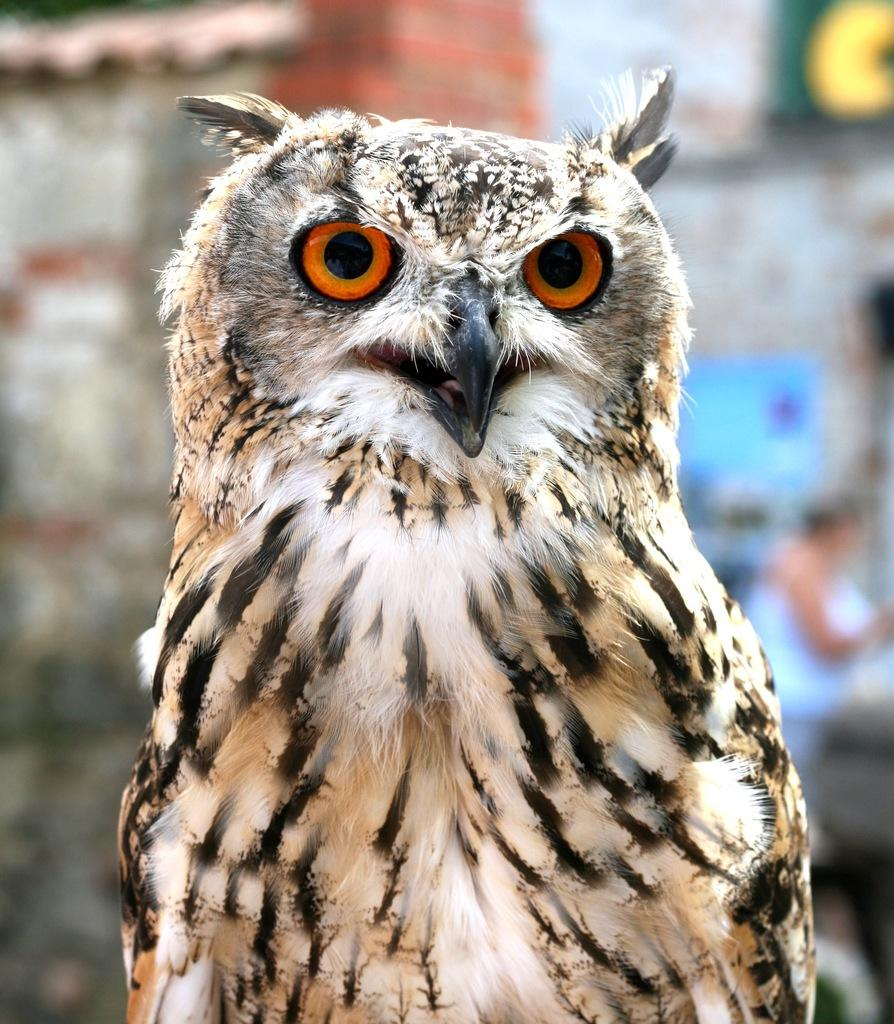What animal is present in the image? There is an owl in the image. What is the owl doing in the image? The owl is standing in the image. Can you describe the background of the image? The background of the image is blurred. What type of treatment is the owl receiving in the image? There is no indication in the image that the owl is receiving any treatment. 